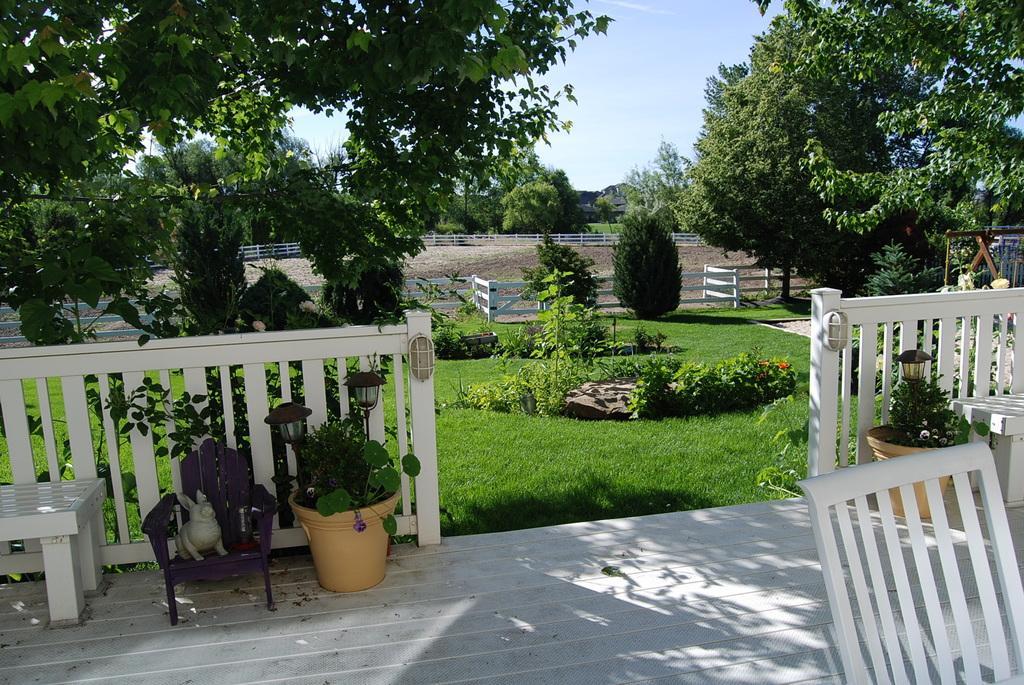In one or two sentences, can you explain what this image depicts? In the image we can see some trees and sky. In the center we can see grass and plants ,which was surrounded by fence. And in the front bottom we can see road,and in the right side corner we can see the chair. And on the left side we can see table, bedside table there is a chair,on chair there is a doll,And side of chair there is a plant pot. 